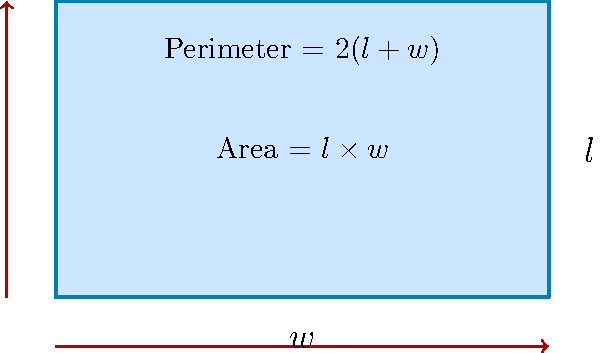As a data center cooling efficiency expert, you're tasked with optimizing the design of rectangular server room layouts. Given that the perimeter-to-area ratio affects cooling efficiency, and you have a fixed area of 60 square meters for each server room, what dimensions (length and width) would result in the most efficient cooling setup? Assume that a lower perimeter-to-area ratio is more efficient for cooling. Let's approach this step-by-step:

1) We know the area is fixed at 60 square meters. Let's denote length as $l$ and width as $w$.

   Area = $l \times w = 60$

2) We need to minimize the perimeter-to-area ratio. The perimeter is given by $2(l + w)$.

   Perimeter-to-Area ratio = $\frac{2(l + w)}{lw}$

3) Given that $lw = 60$, we can express $w$ in terms of $l$:

   $w = \frac{60}{l}$

4) Now, let's substitute this into our ratio:

   Ratio = $\frac{2(l + \frac{60}{l})}{60}$ = $\frac{2l + \frac{120}{l}}{60}$

5) To find the minimum value of this ratio, we can differentiate it with respect to $l$ and set it to zero:

   $\frac{d}{dl}(\frac{2l + \frac{120}{l}}{60}) = \frac{2 - \frac{120}{l^2}}{60} = 0$

6) Solving this equation:

   $2 - \frac{120}{l^2} = 0$
   $2l^2 = 120$
   $l^2 = 60$
   $l = \sqrt{60} \approx 7.746$ meters

7) Since $w = \frac{60}{l}$, $w$ will also equal $\sqrt{60}$.

8) Therefore, the most efficient shape is a square with sides of length $\sqrt{60}$ meters.

This makes intuitive sense, as a square has the smallest perimeter for a given area among all rectangles.
Answer: $l = w = \sqrt{60} \approx 7.746$ meters 